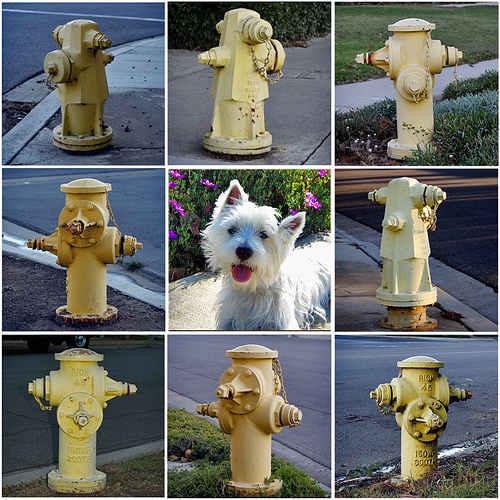Please identify all text content in this image. 46 